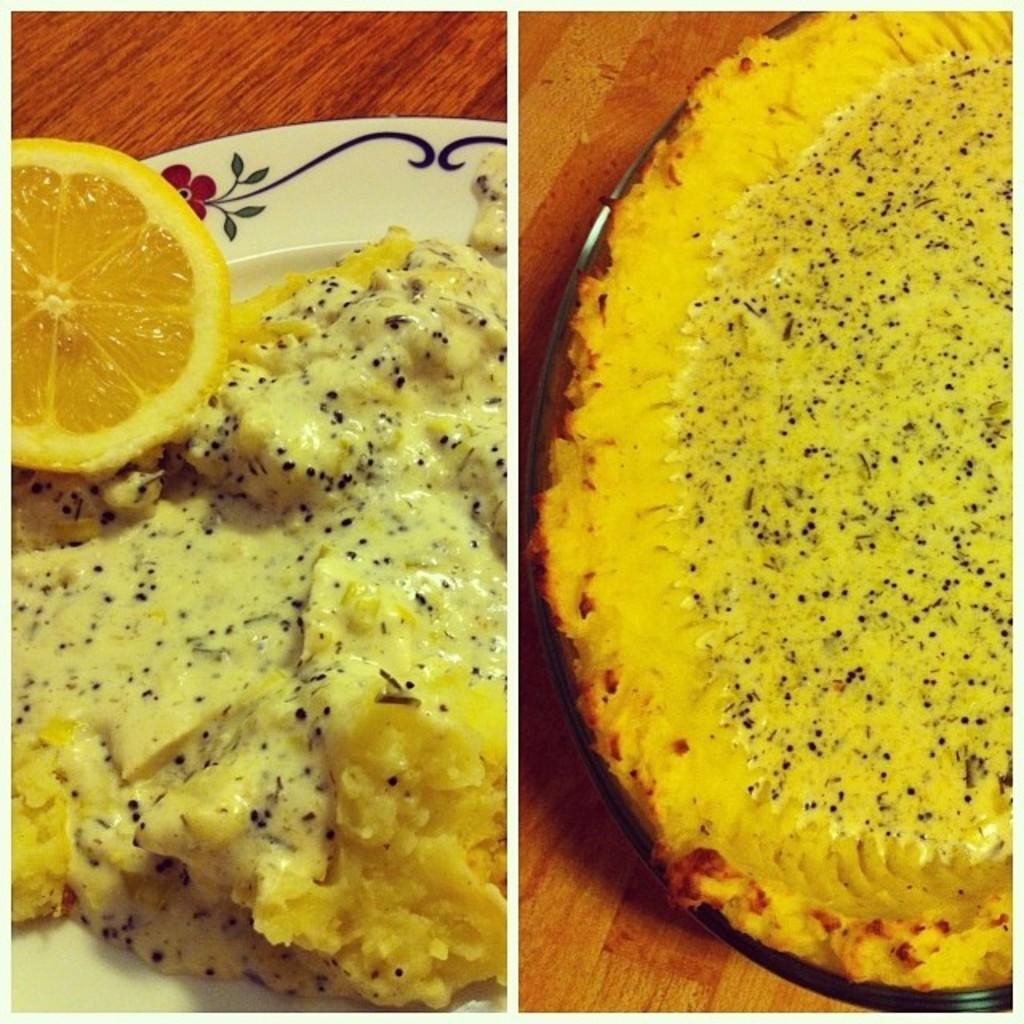What type of artwork is featured in the image? The image contains a collage. What elements can be found within the collage? There is food in the collage, including a piece of lemon in a plate. What is the plate placed on? The plate is placed on a wooden surface. Can you see any steam coming from the lemon in the image? No, there is no steam visible in the image. How many trees are present in the image? There are no trees visible in the image. 